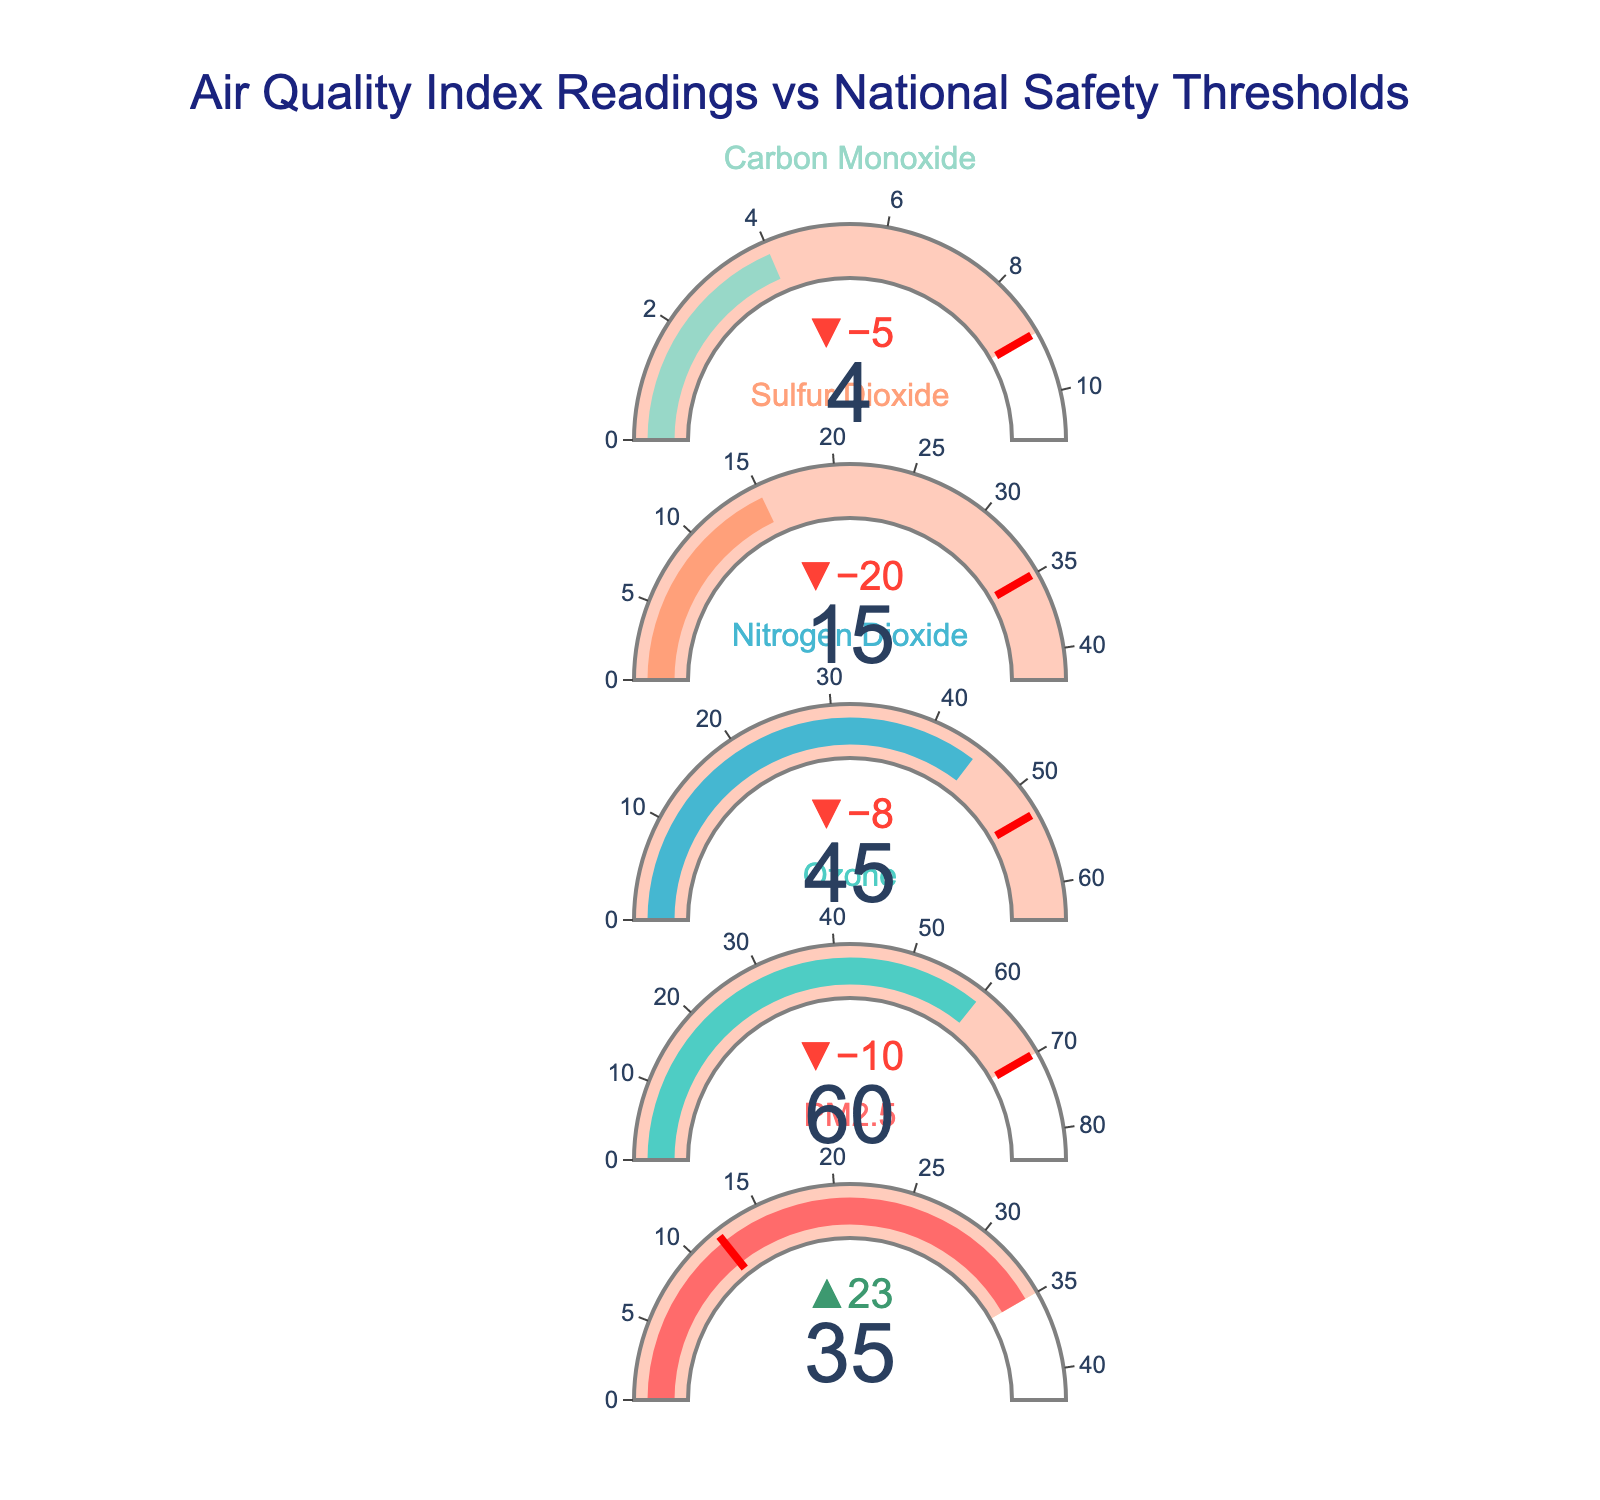What's the title of the figure? The title of the figure is shown prominently at the top and reads "Air Quality Index Readings vs National Safety Thresholds."
Answer: Air Quality Index Readings vs National Safety Thresholds How many air quality categories are listed in the figure? The figure lists five different categories of air quality: PM2.5, Ozone, Nitrogen Dioxide, Sulfur Dioxide, and Carbon Monoxide.
Answer: 5 Which air quality category has the largest value for "Poor"? By examining the "Poor" range, Nitrogen Dioxide has the largest value for "Poor" with a value of 100.
Answer: Nitrogen Dioxide What is the actual reading for Carbon Monoxide, and how does it compare to the national safety threshold? The actual reading for Carbon Monoxide is 4, which is below the national safety threshold (target) of 9.
Answer: 4, below How much higher is the actual PM2.5 reading compared to the national safety threshold? The actual reading for PM2.5 is 35, and the threshold is 12. The difference is 35 - 12 = 23.
Answer: 23 What is the average of the "Fair" values across all categories? The "Fair" values for the categories are 35 (PM2.5), 70 (Ozone), 100 (Nitrogen Dioxide), 75 (Sulfur Dioxide), and 9 (Carbon Monoxide). The average is (35 + 70 + 100 + 75 + 9)/5 = 57.8.
Answer: 57.8 Which category has an actual reading closest to its target? By comparing the actual readings to their targets, Carbon Monoxide is closest with an actual reading of 4 and a target of 9, a difference of 5.
Answer: Carbon Monoxide Are there any categories where the actual reading exceeds the "Good" range? PM2.5 has an actual reading of 35, which exceeds its "Good" range of 9-12, and Nitrogen Dioxide has an actual reading of 45, exceeding its "Good" range of 40-53.
Answer: PM2.5, Nitrogen Dioxide Which category has the smallest difference between the actual reading and the national safety threshold? Considering the differences: PM2.5 (23), Ozone (-10), Nitrogen Dioxide (-8), Sulfur Dioxide (-20), Carbon Monoxide (-5), the smallest difference is Carbon Monoxide with a difference of 5.
Answer: Carbon Monoxide 